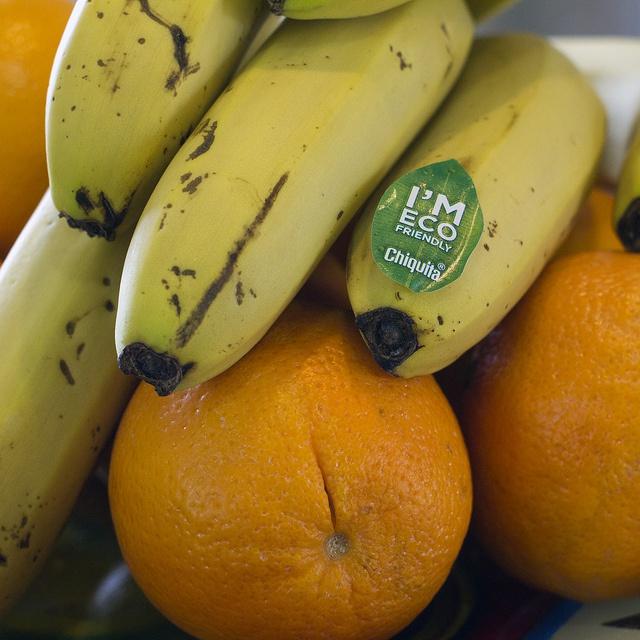Describe the objects in this image and their specific colors. I can see banana in orange, tan, and olive tones, orange in orange, olive, and maroon tones, orange in orange, olive, maroon, and black tones, orange in orange, olive, and maroon tones, and orange in orange, olive, maroon, and black tones in this image. 